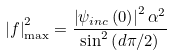<formula> <loc_0><loc_0><loc_500><loc_500>\left | f \right | _ { \max } ^ { 2 } = \frac { \left | \psi _ { i n c } \left ( 0 \right ) \right | ^ { 2 } \alpha ^ { 2 } } { \sin ^ { 2 } \left ( d \pi / 2 \right ) }</formula> 